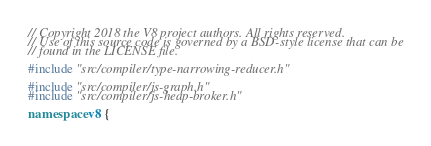<code> <loc_0><loc_0><loc_500><loc_500><_C++_>// Copyright 2018 the V8 project authors. All rights reserved.
// Use of this source code is governed by a BSD-style license that can be
// found in the LICENSE file.

#include "src/compiler/type-narrowing-reducer.h"

#include "src/compiler/js-graph.h"
#include "src/compiler/js-heap-broker.h"

namespace v8 {</code> 